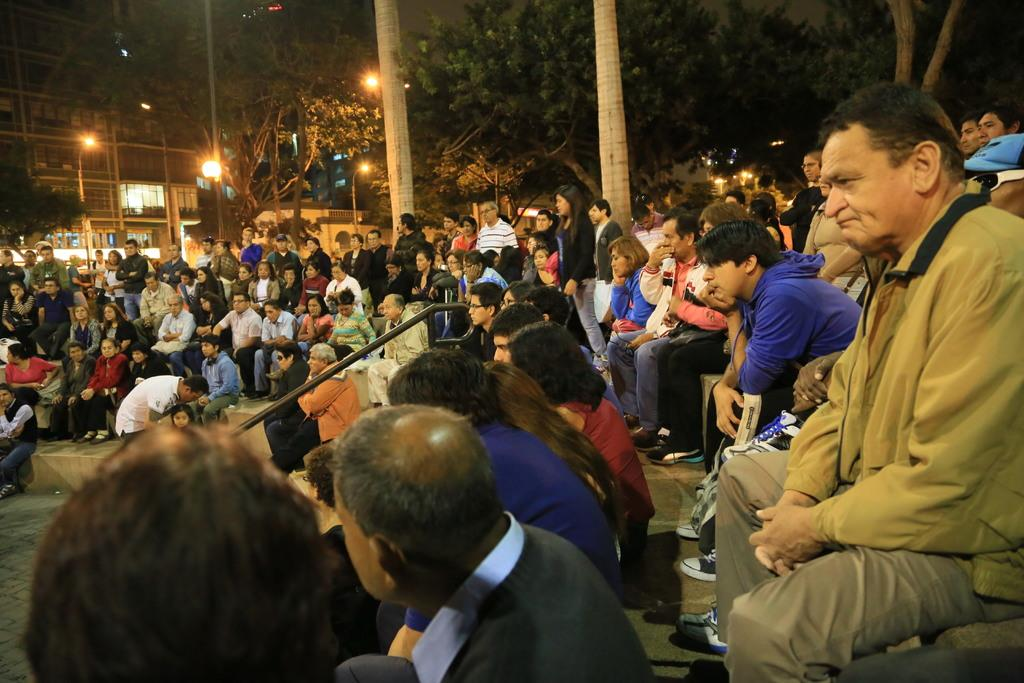How many people are in the image? There is a group of people in the image. What are some of the people in the image doing? Some people are sitting on steps, while others are standing. What can be seen in the background of the image? There are trees, lights, and buildings in the background of the image. What type of spark can be seen coming from the baby in the image? There is no baby present in the image, and therefore no spark can be seen coming from a baby. 